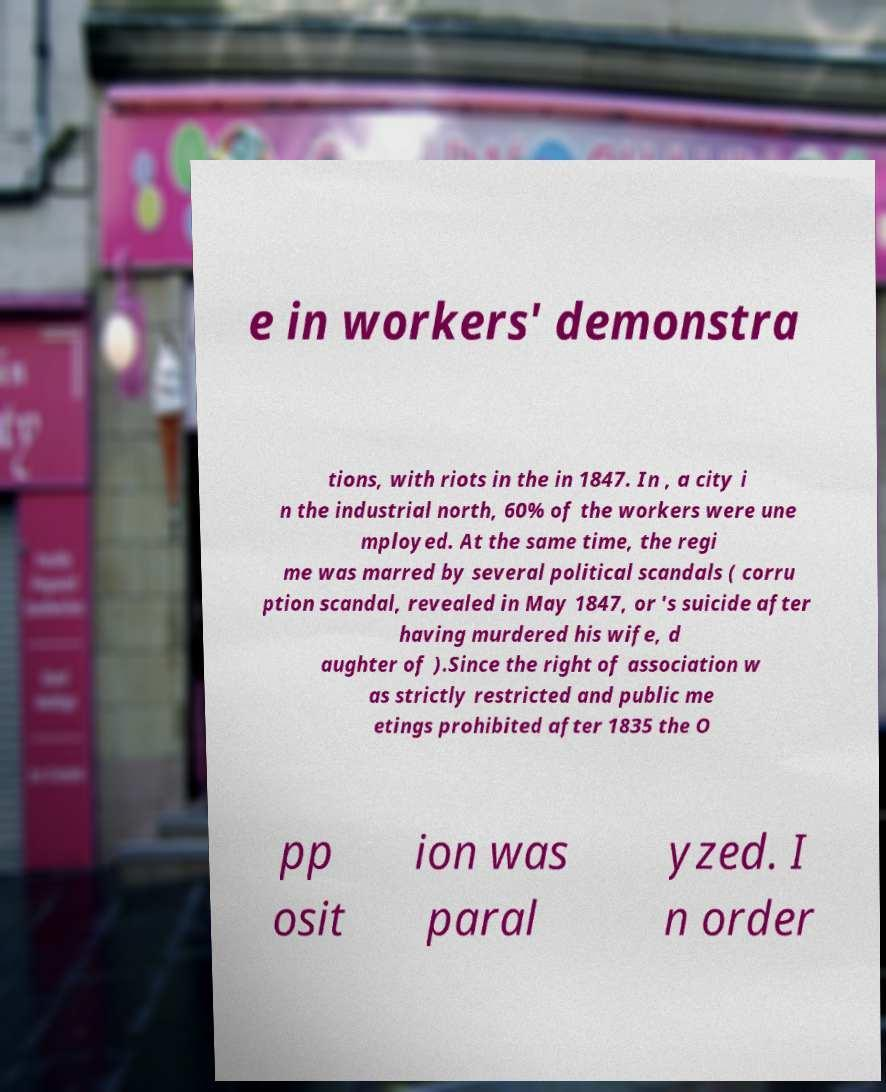Please read and relay the text visible in this image. What does it say? e in workers' demonstra tions, with riots in the in 1847. In , a city i n the industrial north, 60% of the workers were une mployed. At the same time, the regi me was marred by several political scandals ( corru ption scandal, revealed in May 1847, or 's suicide after having murdered his wife, d aughter of ).Since the right of association w as strictly restricted and public me etings prohibited after 1835 the O pp osit ion was paral yzed. I n order 